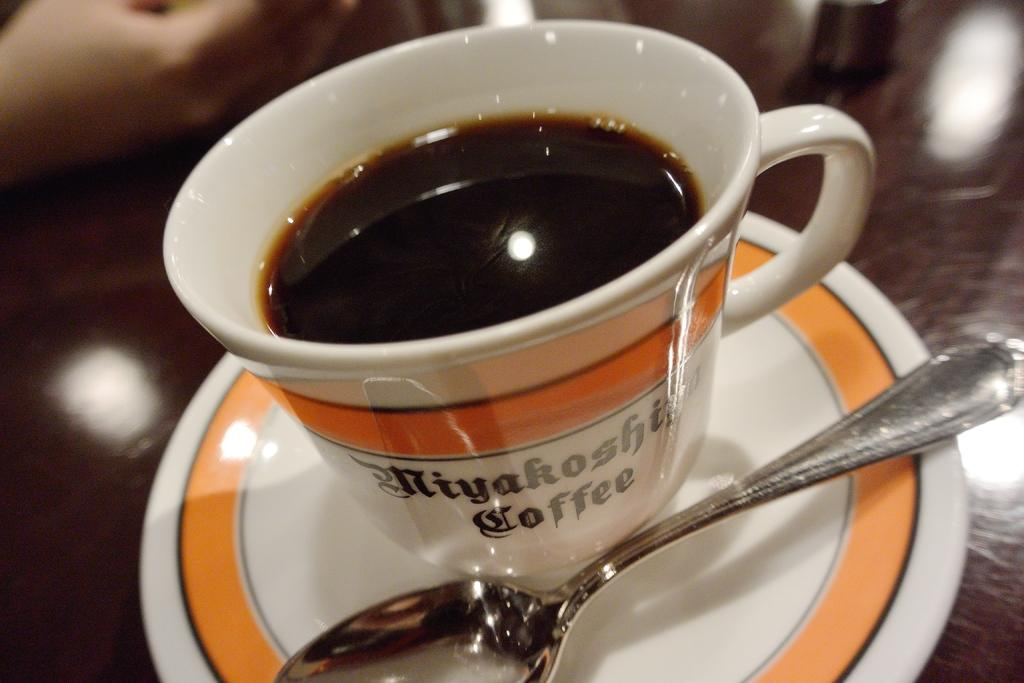What is present in the image along with the cup? There is a saucer and a spoon in the image. How is the spoon positioned in relation to the saucer? The spoon is placed on the saucer. What might be inside the cup? The cup is likely filled with a liquid. Can you describe the background of the image? The background of the image appears blurry. What type of list can be seen on the cup in the image? There is no list present on the cup in the image. What type of eggnog is being served in the cup? There is no indication of the specific type of liquid in the cup, and eggnog is not mentioned in the facts provided. 